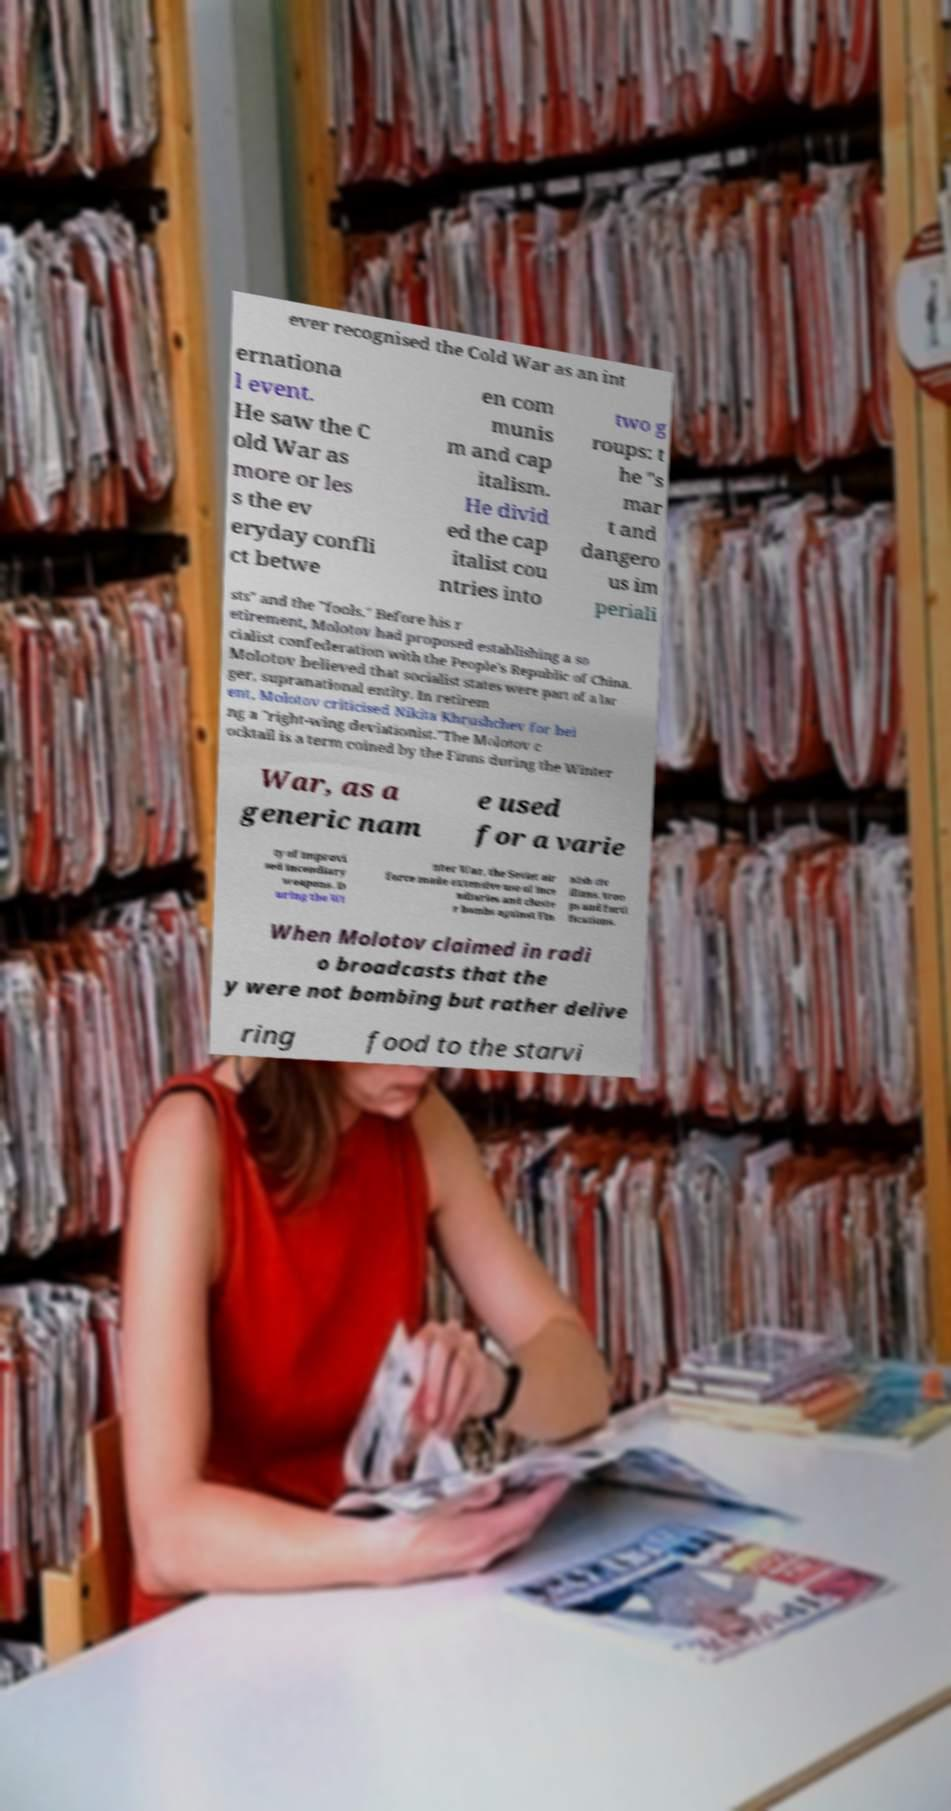Please identify and transcribe the text found in this image. ever recognised the Cold War as an int ernationa l event. He saw the C old War as more or les s the ev eryday confli ct betwe en com munis m and cap italism. He divid ed the cap italist cou ntries into two g roups: t he "s mar t and dangero us im periali sts" and the "fools." Before his r etirement, Molotov had proposed establishing a so cialist confederation with the People's Republic of China. Molotov believed that socialist states were part of a lar ger, supranational entity. In retirem ent, Molotov criticised Nikita Khrushchev for bei ng a "right-wing deviationist."The Molotov c ocktail is a term coined by the Finns during the Winter War, as a generic nam e used for a varie ty of improvi sed incendiary weapons. D uring the Wi nter War, the Soviet air force made extensive use of ince ndiaries and cluste r bombs against Fin nish civ ilians, troo ps and forti fications. When Molotov claimed in radi o broadcasts that the y were not bombing but rather delive ring food to the starvi 